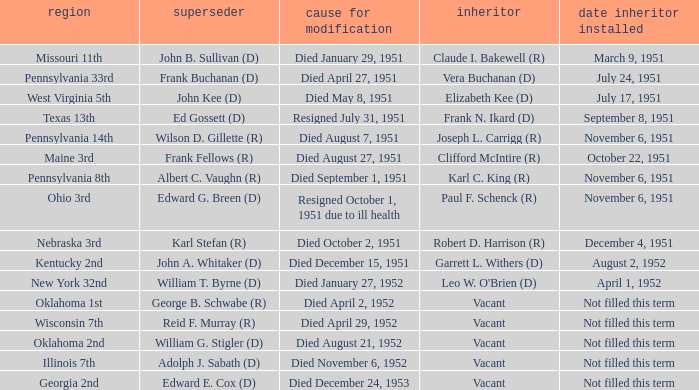Who was the successor for the Kentucky 2nd district? Garrett L. Withers (D). 